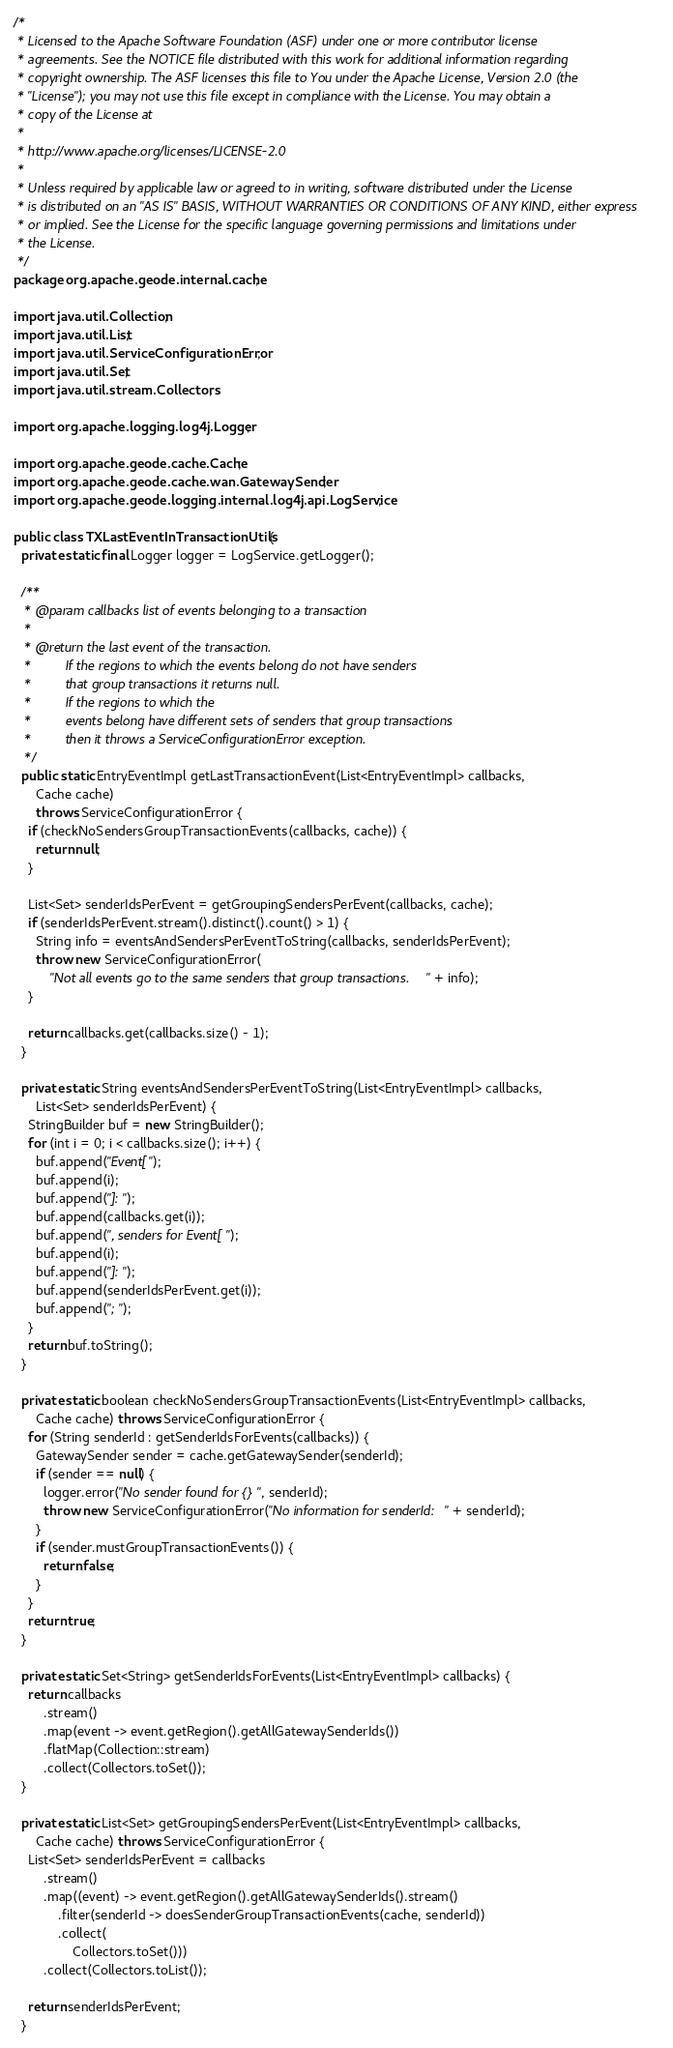<code> <loc_0><loc_0><loc_500><loc_500><_Java_>/*
 * Licensed to the Apache Software Foundation (ASF) under one or more contributor license
 * agreements. See the NOTICE file distributed with this work for additional information regarding
 * copyright ownership. The ASF licenses this file to You under the Apache License, Version 2.0 (the
 * "License"); you may not use this file except in compliance with the License. You may obtain a
 * copy of the License at
 *
 * http://www.apache.org/licenses/LICENSE-2.0
 *
 * Unless required by applicable law or agreed to in writing, software distributed under the License
 * is distributed on an "AS IS" BASIS, WITHOUT WARRANTIES OR CONDITIONS OF ANY KIND, either express
 * or implied. See the License for the specific language governing permissions and limitations under
 * the License.
 */
package org.apache.geode.internal.cache;

import java.util.Collection;
import java.util.List;
import java.util.ServiceConfigurationError;
import java.util.Set;
import java.util.stream.Collectors;

import org.apache.logging.log4j.Logger;

import org.apache.geode.cache.Cache;
import org.apache.geode.cache.wan.GatewaySender;
import org.apache.geode.logging.internal.log4j.api.LogService;

public class TXLastEventInTransactionUtils {
  private static final Logger logger = LogService.getLogger();

  /**
   * @param callbacks list of events belonging to a transaction
   *
   * @return the last event of the transaction.
   *         If the regions to which the events belong do not have senders
   *         that group transactions it returns null.
   *         If the regions to which the
   *         events belong have different sets of senders that group transactions
   *         then it throws a ServiceConfigurationError exception.
   */
  public static EntryEventImpl getLastTransactionEvent(List<EntryEventImpl> callbacks,
      Cache cache)
      throws ServiceConfigurationError {
    if (checkNoSendersGroupTransactionEvents(callbacks, cache)) {
      return null;
    }

    List<Set> senderIdsPerEvent = getGroupingSendersPerEvent(callbacks, cache);
    if (senderIdsPerEvent.stream().distinct().count() > 1) {
      String info = eventsAndSendersPerEventToString(callbacks, senderIdsPerEvent);
      throw new ServiceConfigurationError(
          "Not all events go to the same senders that group transactions. " + info);
    }

    return callbacks.get(callbacks.size() - 1);
  }

  private static String eventsAndSendersPerEventToString(List<EntryEventImpl> callbacks,
      List<Set> senderIdsPerEvent) {
    StringBuilder buf = new StringBuilder();
    for (int i = 0; i < callbacks.size(); i++) {
      buf.append("Event[");
      buf.append(i);
      buf.append("]: ");
      buf.append(callbacks.get(i));
      buf.append(", senders for Event[");
      buf.append(i);
      buf.append("]: ");
      buf.append(senderIdsPerEvent.get(i));
      buf.append("; ");
    }
    return buf.toString();
  }

  private static boolean checkNoSendersGroupTransactionEvents(List<EntryEventImpl> callbacks,
      Cache cache) throws ServiceConfigurationError {
    for (String senderId : getSenderIdsForEvents(callbacks)) {
      GatewaySender sender = cache.getGatewaySender(senderId);
      if (sender == null) {
        logger.error("No sender found for {}", senderId);
        throw new ServiceConfigurationError("No information for senderId: " + senderId);
      }
      if (sender.mustGroupTransactionEvents()) {
        return false;
      }
    }
    return true;
  }

  private static Set<String> getSenderIdsForEvents(List<EntryEventImpl> callbacks) {
    return callbacks
        .stream()
        .map(event -> event.getRegion().getAllGatewaySenderIds())
        .flatMap(Collection::stream)
        .collect(Collectors.toSet());
  }

  private static List<Set> getGroupingSendersPerEvent(List<EntryEventImpl> callbacks,
      Cache cache) throws ServiceConfigurationError {
    List<Set> senderIdsPerEvent = callbacks
        .stream()
        .map((event) -> event.getRegion().getAllGatewaySenderIds().stream()
            .filter(senderId -> doesSenderGroupTransactionEvents(cache, senderId))
            .collect(
                Collectors.toSet()))
        .collect(Collectors.toList());

    return senderIdsPerEvent;
  }
</code> 